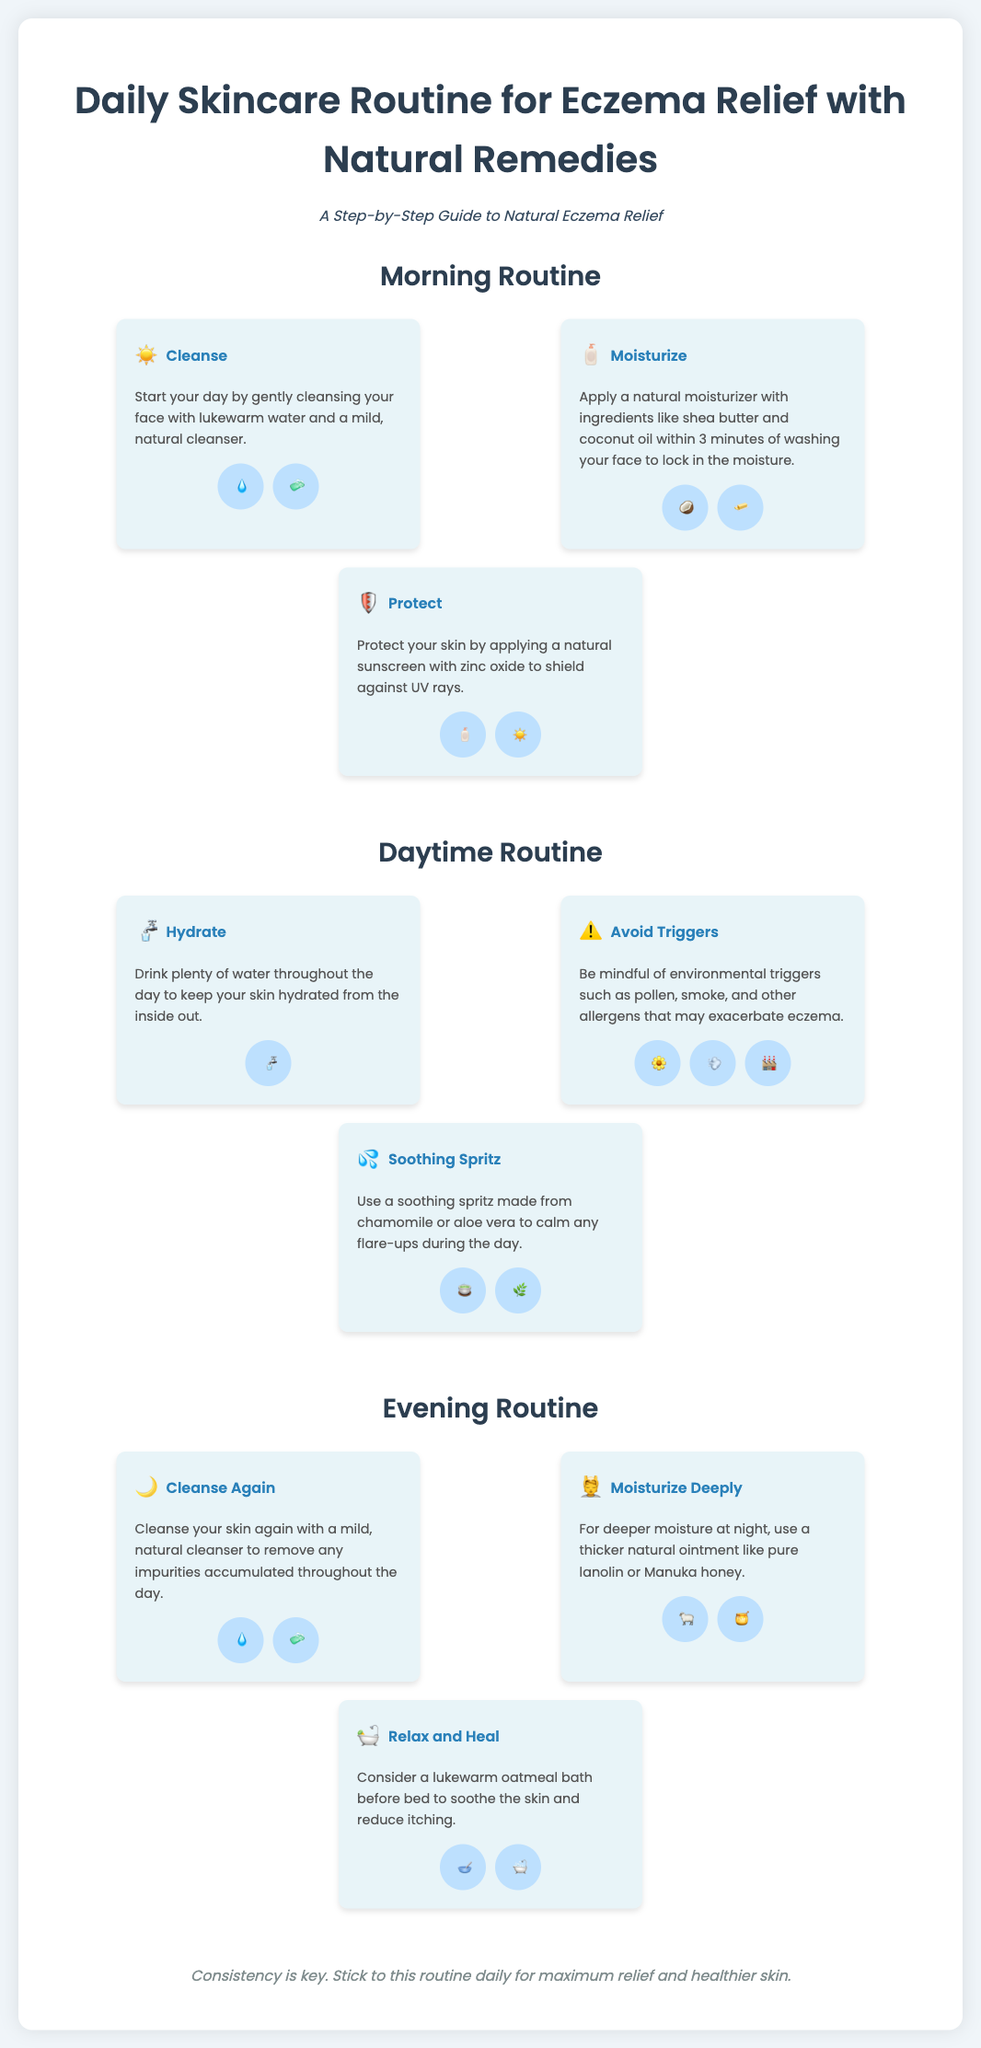What is the first step in the morning routine? The first step in the morning routine is to cleanse your face with lukewarm water and a mild, natural cleanser.
Answer: Cleanse What ingredient is recommended for deep moisture at night? A thicker natural ointment like pure lanolin or Manuka honey is recommended for deeper moisture at night.
Answer: Pure lanolin or Manuka honey How many steps are there in the evening routine? The evening routine includes three steps: cleanse again, moisturize deeply, and relax and heal.
Answer: Three What natural ingredient can be used in a soothing spritz? Chamomile or aloe vera can be used to make a soothing spritz to calm flare-ups during the day.
Answer: Chamomile or aloe vera Which step involves using zinc oxide? The step that involves using zinc oxide is Protect, which shields against UV rays.
Answer: Protect How long after washing your face should you moisturize? You should apply a natural moisturizer within 3 minutes of washing your face to lock in moisture.
Answer: 3 minutes What is key for maximum relief and healthier skin? Consistency is key for maximum relief and healthier skin.
Answer: Consistency What type of bath is recommended before bed? A lukewarm oatmeal bath is recommended before bed to soothe the skin and reduce itching.
Answer: Lukewarm oatmeal bath 